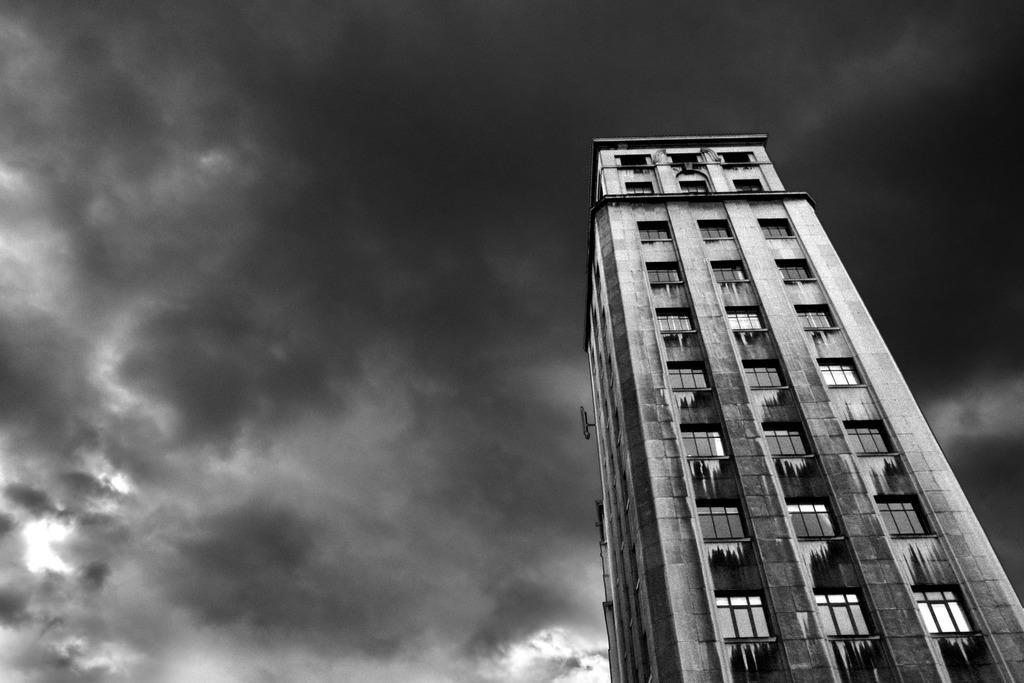Describe this image in one or two sentences. This is a black and white picture. I can see a building, and in the background there is the sky. 